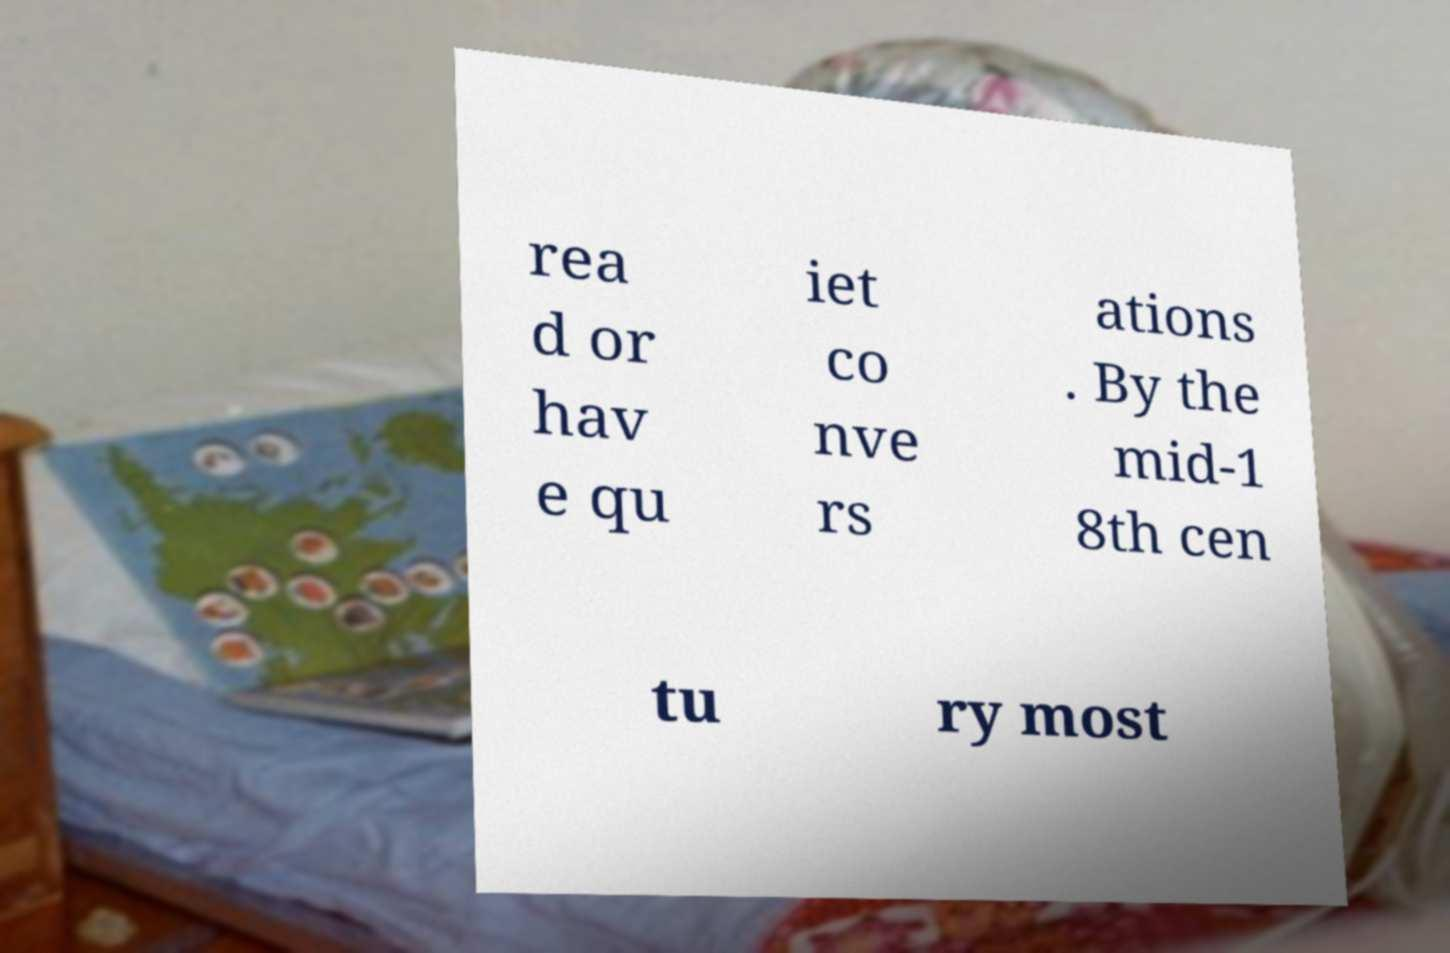Can you read and provide the text displayed in the image?This photo seems to have some interesting text. Can you extract and type it out for me? rea d or hav e qu iet co nve rs ations . By the mid-1 8th cen tu ry most 